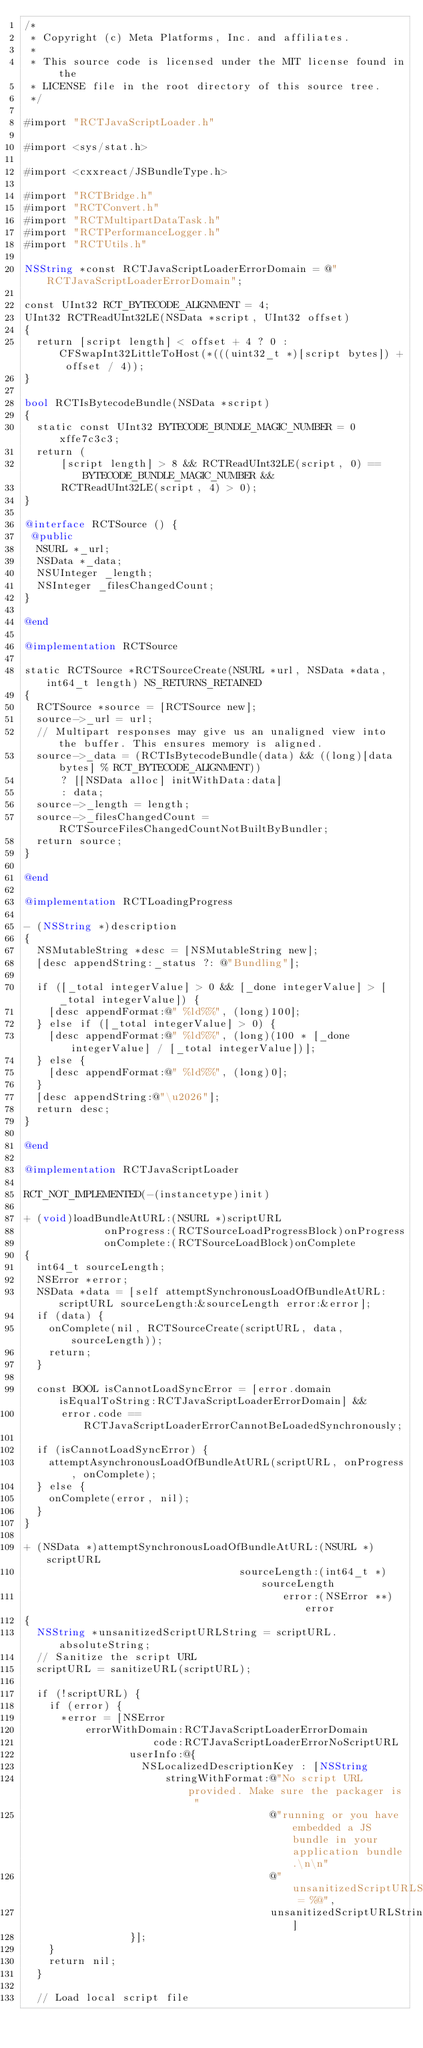Convert code to text. <code><loc_0><loc_0><loc_500><loc_500><_ObjectiveC_>/*
 * Copyright (c) Meta Platforms, Inc. and affiliates.
 *
 * This source code is licensed under the MIT license found in the
 * LICENSE file in the root directory of this source tree.
 */

#import "RCTJavaScriptLoader.h"

#import <sys/stat.h>

#import <cxxreact/JSBundleType.h>

#import "RCTBridge.h"
#import "RCTConvert.h"
#import "RCTMultipartDataTask.h"
#import "RCTPerformanceLogger.h"
#import "RCTUtils.h"

NSString *const RCTJavaScriptLoaderErrorDomain = @"RCTJavaScriptLoaderErrorDomain";

const UInt32 RCT_BYTECODE_ALIGNMENT = 4;
UInt32 RCTReadUInt32LE(NSData *script, UInt32 offset)
{
  return [script length] < offset + 4 ? 0 : CFSwapInt32LittleToHost(*(((uint32_t *)[script bytes]) + offset / 4));
}

bool RCTIsBytecodeBundle(NSData *script)
{
  static const UInt32 BYTECODE_BUNDLE_MAGIC_NUMBER = 0xffe7c3c3;
  return (
      [script length] > 8 && RCTReadUInt32LE(script, 0) == BYTECODE_BUNDLE_MAGIC_NUMBER &&
      RCTReadUInt32LE(script, 4) > 0);
}

@interface RCTSource () {
 @public
  NSURL *_url;
  NSData *_data;
  NSUInteger _length;
  NSInteger _filesChangedCount;
}

@end

@implementation RCTSource

static RCTSource *RCTSourceCreate(NSURL *url, NSData *data, int64_t length) NS_RETURNS_RETAINED
{
  RCTSource *source = [RCTSource new];
  source->_url = url;
  // Multipart responses may give us an unaligned view into the buffer. This ensures memory is aligned.
  source->_data = (RCTIsBytecodeBundle(data) && ((long)[data bytes] % RCT_BYTECODE_ALIGNMENT))
      ? [[NSData alloc] initWithData:data]
      : data;
  source->_length = length;
  source->_filesChangedCount = RCTSourceFilesChangedCountNotBuiltByBundler;
  return source;
}

@end

@implementation RCTLoadingProgress

- (NSString *)description
{
  NSMutableString *desc = [NSMutableString new];
  [desc appendString:_status ?: @"Bundling"];

  if ([_total integerValue] > 0 && [_done integerValue] > [_total integerValue]) {
    [desc appendFormat:@" %ld%%", (long)100];
  } else if ([_total integerValue] > 0) {
    [desc appendFormat:@" %ld%%", (long)(100 * [_done integerValue] / [_total integerValue])];
  } else {
    [desc appendFormat:@" %ld%%", (long)0];
  }
  [desc appendString:@"\u2026"];
  return desc;
}

@end

@implementation RCTJavaScriptLoader

RCT_NOT_IMPLEMENTED(-(instancetype)init)

+ (void)loadBundleAtURL:(NSURL *)scriptURL
             onProgress:(RCTSourceLoadProgressBlock)onProgress
             onComplete:(RCTSourceLoadBlock)onComplete
{
  int64_t sourceLength;
  NSError *error;
  NSData *data = [self attemptSynchronousLoadOfBundleAtURL:scriptURL sourceLength:&sourceLength error:&error];
  if (data) {
    onComplete(nil, RCTSourceCreate(scriptURL, data, sourceLength));
    return;
  }

  const BOOL isCannotLoadSyncError = [error.domain isEqualToString:RCTJavaScriptLoaderErrorDomain] &&
      error.code == RCTJavaScriptLoaderErrorCannotBeLoadedSynchronously;

  if (isCannotLoadSyncError) {
    attemptAsynchronousLoadOfBundleAtURL(scriptURL, onProgress, onComplete);
  } else {
    onComplete(error, nil);
  }
}

+ (NSData *)attemptSynchronousLoadOfBundleAtURL:(NSURL *)scriptURL
                                   sourceLength:(int64_t *)sourceLength
                                          error:(NSError **)error
{
  NSString *unsanitizedScriptURLString = scriptURL.absoluteString;
  // Sanitize the script URL
  scriptURL = sanitizeURL(scriptURL);

  if (!scriptURL) {
    if (error) {
      *error = [NSError
          errorWithDomain:RCTJavaScriptLoaderErrorDomain
                     code:RCTJavaScriptLoaderErrorNoScriptURL
                 userInfo:@{
                   NSLocalizedDescriptionKey : [NSString
                       stringWithFormat:@"No script URL provided. Make sure the packager is "
                                        @"running or you have embedded a JS bundle in your application bundle.\n\n"
                                        @"unsanitizedScriptURLString = %@",
                                        unsanitizedScriptURLString]
                 }];
    }
    return nil;
  }

  // Load local script file</code> 